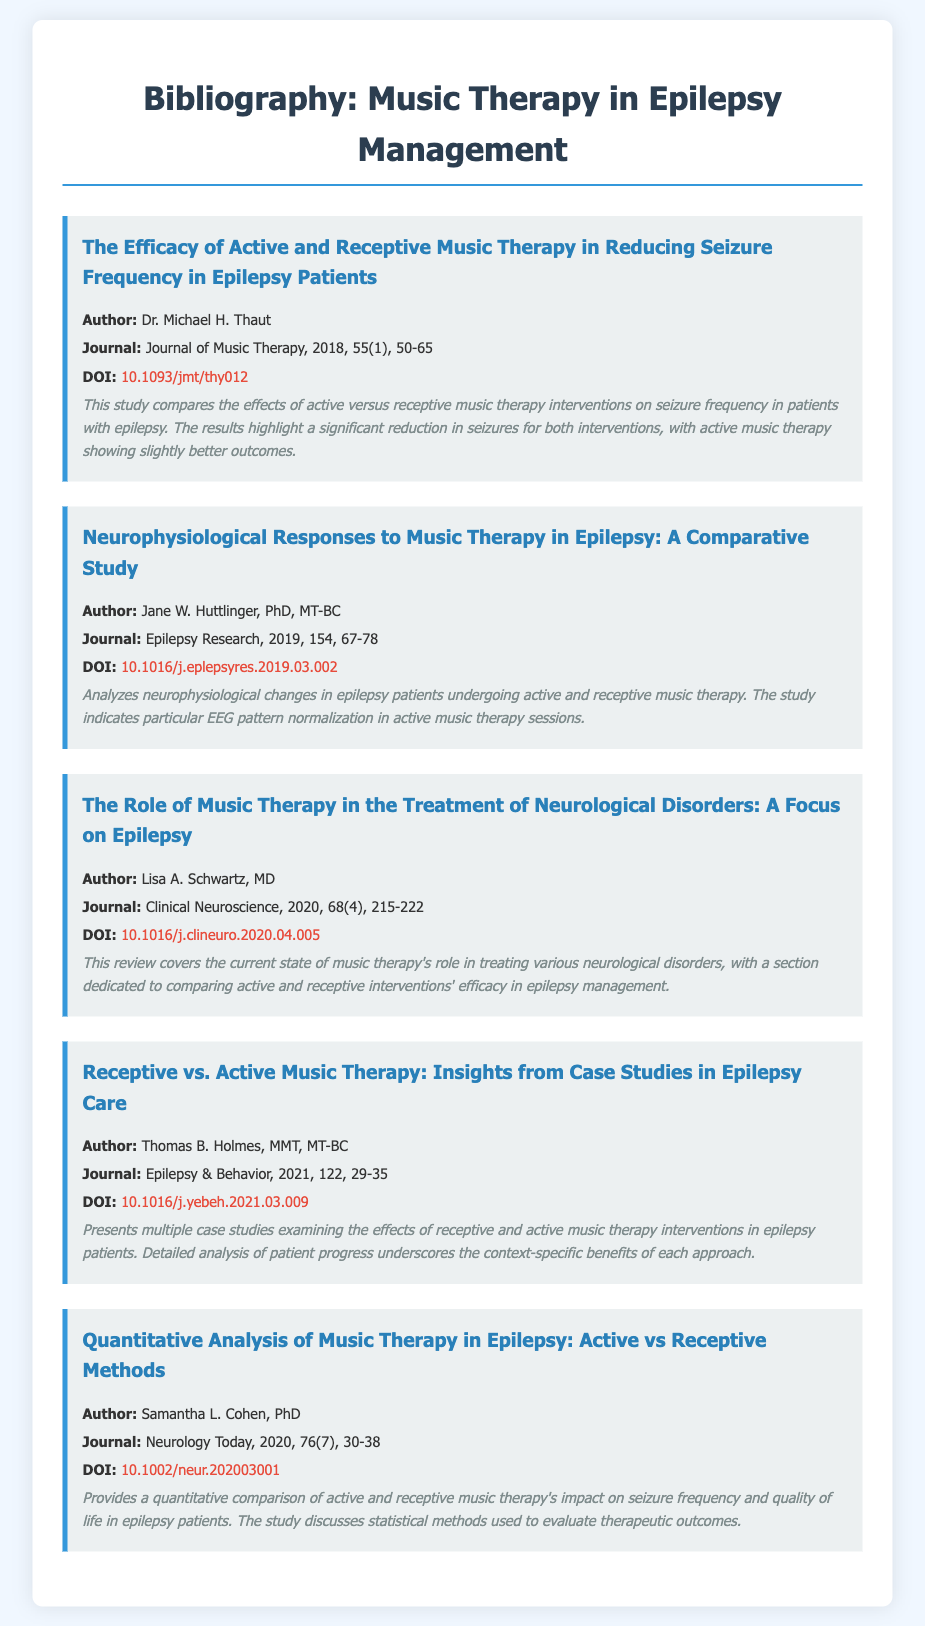What is the title of the first entry? The title is stated at the beginning of each entry in the document.
Answer: The Efficacy of Active and Receptive Music Therapy in Reducing Seizure Frequency in Epilepsy Patients Who is the author of the second entry? Each entry lists the author immediately following the title, which can be used for identification.
Answer: Jane W. Huttlinger, PhD, MT-BC What is the DOI of the fourth entry? The DOI is provided as a hyperlink at the end of each entry.
Answer: 10.1016/j.yebeh.2021.03.009 Which journal published the study by Dr. Michael H. Thaut? The journal is listed in each entry under the author information.
Answer: Journal of Music Therapy What year was the article by Lisa A. Schwartz published? The year of publication is included within the journal citation in each entry.
Answer: 2020 Which intervention showed slightly better outcomes in seizure reduction? The comparative analysis in the abstract describes the results briefly.
Answer: Active music therapy What is the focus of the third entry? The abstract summarizes the main theme and content of the entry clearly.
Answer: Role of music therapy in the treatment of neurological disorders What type of studies does the fourth entry primarily present? The abstract or title helps identify the method or format of the research presented.
Answer: Case studies Which publication year and volume number correspond to the article by Samantha L. Cohen? This information is given directly in the citation within the entry.
Answer: 2020, 76(7) 